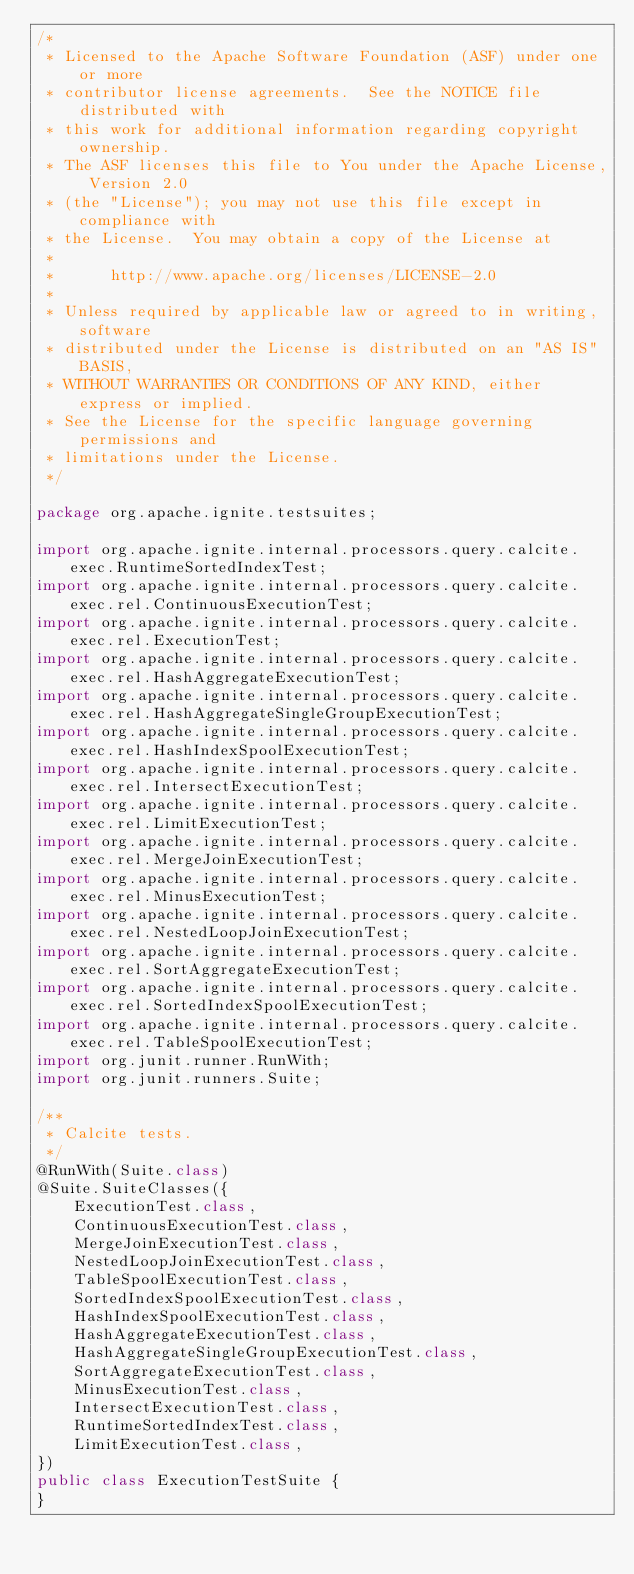<code> <loc_0><loc_0><loc_500><loc_500><_Java_>/*
 * Licensed to the Apache Software Foundation (ASF) under one or more
 * contributor license agreements.  See the NOTICE file distributed with
 * this work for additional information regarding copyright ownership.
 * The ASF licenses this file to You under the Apache License, Version 2.0
 * (the "License"); you may not use this file except in compliance with
 * the License.  You may obtain a copy of the License at
 *
 *      http://www.apache.org/licenses/LICENSE-2.0
 *
 * Unless required by applicable law or agreed to in writing, software
 * distributed under the License is distributed on an "AS IS" BASIS,
 * WITHOUT WARRANTIES OR CONDITIONS OF ANY KIND, either express or implied.
 * See the License for the specific language governing permissions and
 * limitations under the License.
 */

package org.apache.ignite.testsuites;

import org.apache.ignite.internal.processors.query.calcite.exec.RuntimeSortedIndexTest;
import org.apache.ignite.internal.processors.query.calcite.exec.rel.ContinuousExecutionTest;
import org.apache.ignite.internal.processors.query.calcite.exec.rel.ExecutionTest;
import org.apache.ignite.internal.processors.query.calcite.exec.rel.HashAggregateExecutionTest;
import org.apache.ignite.internal.processors.query.calcite.exec.rel.HashAggregateSingleGroupExecutionTest;
import org.apache.ignite.internal.processors.query.calcite.exec.rel.HashIndexSpoolExecutionTest;
import org.apache.ignite.internal.processors.query.calcite.exec.rel.IntersectExecutionTest;
import org.apache.ignite.internal.processors.query.calcite.exec.rel.LimitExecutionTest;
import org.apache.ignite.internal.processors.query.calcite.exec.rel.MergeJoinExecutionTest;
import org.apache.ignite.internal.processors.query.calcite.exec.rel.MinusExecutionTest;
import org.apache.ignite.internal.processors.query.calcite.exec.rel.NestedLoopJoinExecutionTest;
import org.apache.ignite.internal.processors.query.calcite.exec.rel.SortAggregateExecutionTest;
import org.apache.ignite.internal.processors.query.calcite.exec.rel.SortedIndexSpoolExecutionTest;
import org.apache.ignite.internal.processors.query.calcite.exec.rel.TableSpoolExecutionTest;
import org.junit.runner.RunWith;
import org.junit.runners.Suite;

/**
 * Calcite tests.
 */
@RunWith(Suite.class)
@Suite.SuiteClasses({
    ExecutionTest.class,
    ContinuousExecutionTest.class,
    MergeJoinExecutionTest.class,
    NestedLoopJoinExecutionTest.class,
    TableSpoolExecutionTest.class,
    SortedIndexSpoolExecutionTest.class,
    HashIndexSpoolExecutionTest.class,
    HashAggregateExecutionTest.class,
    HashAggregateSingleGroupExecutionTest.class,
    SortAggregateExecutionTest.class,
    MinusExecutionTest.class,
    IntersectExecutionTest.class,
    RuntimeSortedIndexTest.class,
    LimitExecutionTest.class,
})
public class ExecutionTestSuite {
}
</code> 